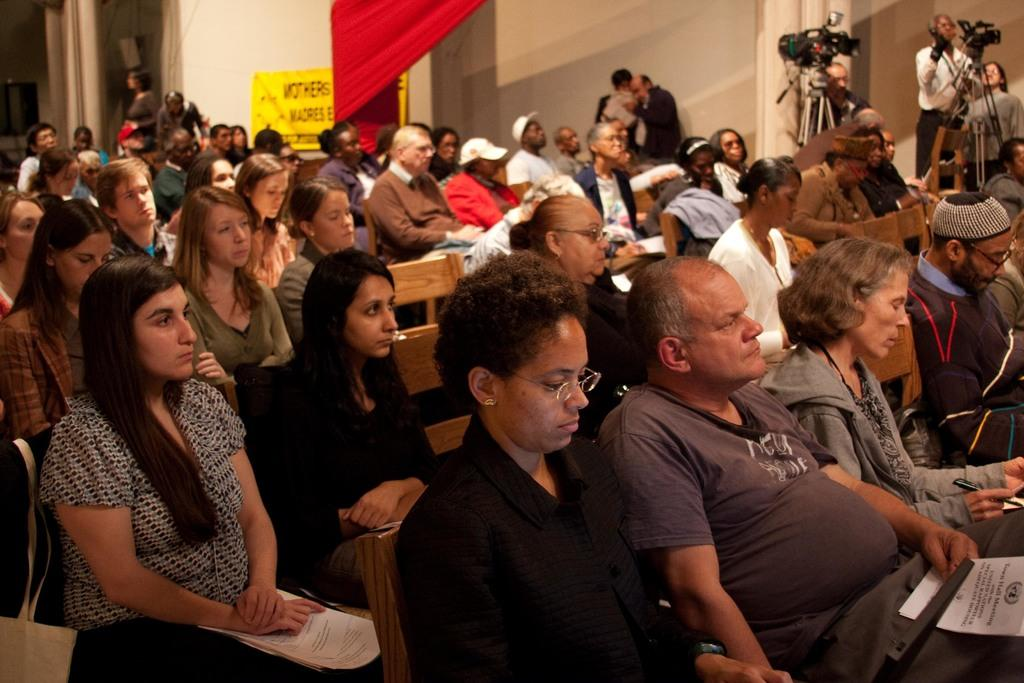What are the people in the image doing? There are people sitting on chairs and standing in the image. What objects are visible in the image that are related to photography? There are cameras visible in the image. What is on the wall in the image? There is a poster with text on the wall in the image. What type of window treatment is present in the image? There is a curtain in the image. What type of quilt is being used to push the people in the image? There is no quilt or pushing action present in the image. 